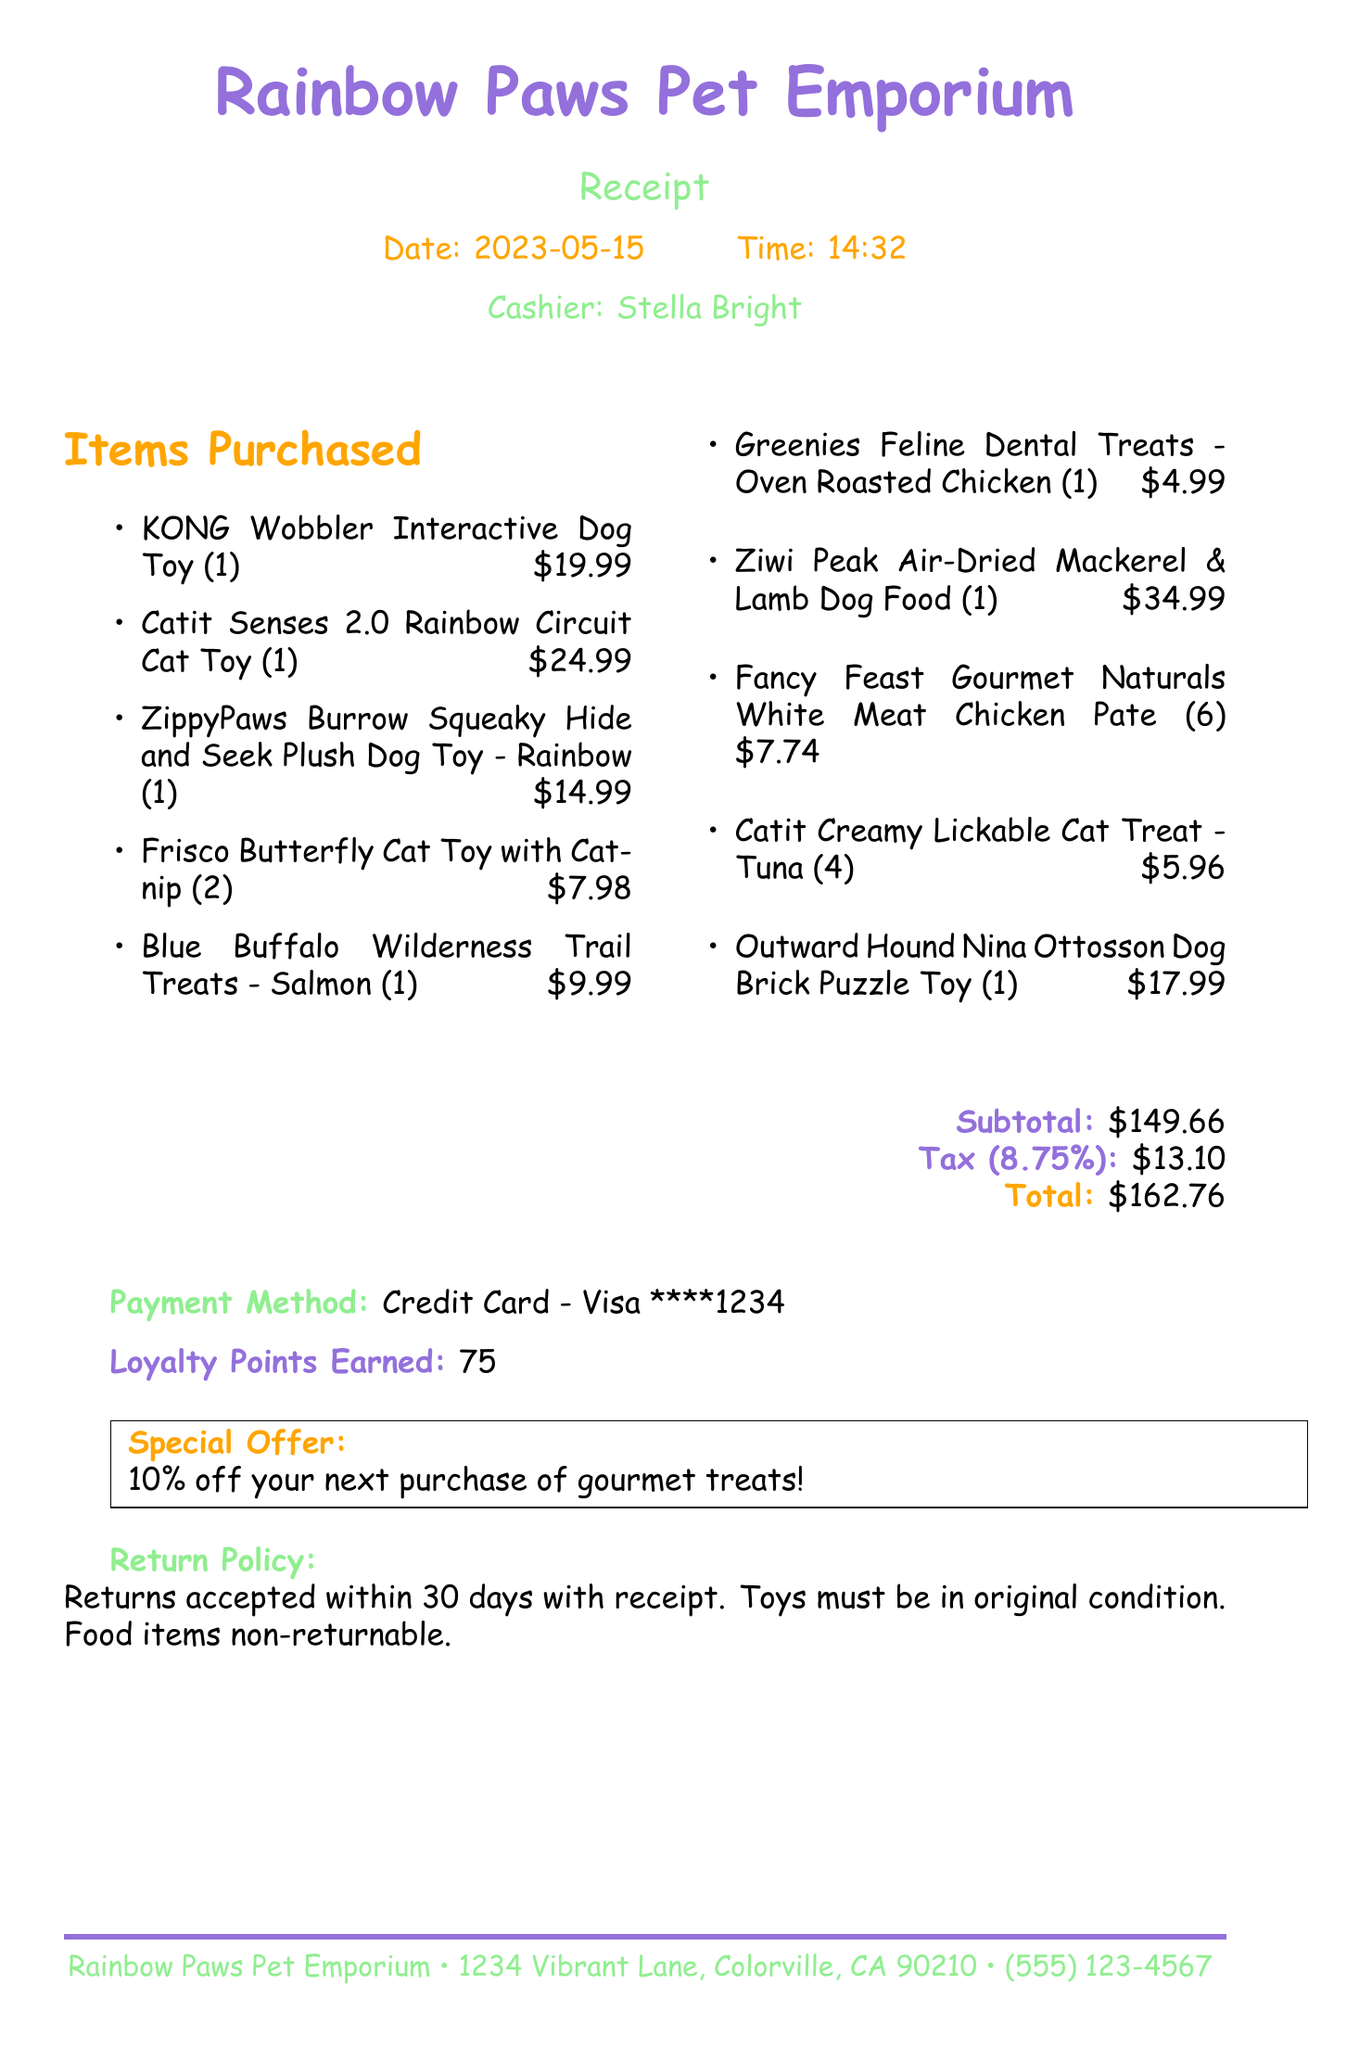What is the name of the pet store? The name of the pet store is listed at the top of the receipt.
Answer: Rainbow Paws Pet Emporium What is the date of purchase? The date is specified in the document as the purchase date.
Answer: 2023-05-15 How many loyalty points were earned? The document mentions the total loyalty points earned at the end.
Answer: 75 What is the price of the Catit Senses 2.0 Rainbow Circuit Cat Toy? The price of this specific toy is indicated next to its name in the items list.
Answer: 24.99 What is the subtotal amount? The subtotal is clearly stated in the receipt as a specific monetary value.
Answer: 149.66 What is the special offer mentioned in the receipt? The special offer is noted in a highlighted box towards the bottom of the receipt.
Answer: 10% off your next purchase of gourmet treats! How many Frisco Butterfly Cat Toys were purchased? The quantity purchased is listed next to the item in the items list.
Answer: 2 What type of food is the Ziwi Peak product? The document specifies the type of food in the item's description.
Answer: Dog Food What is the return policy for toys? The return policy for toys is outlined in the document.
Answer: Toys must be in original condition 